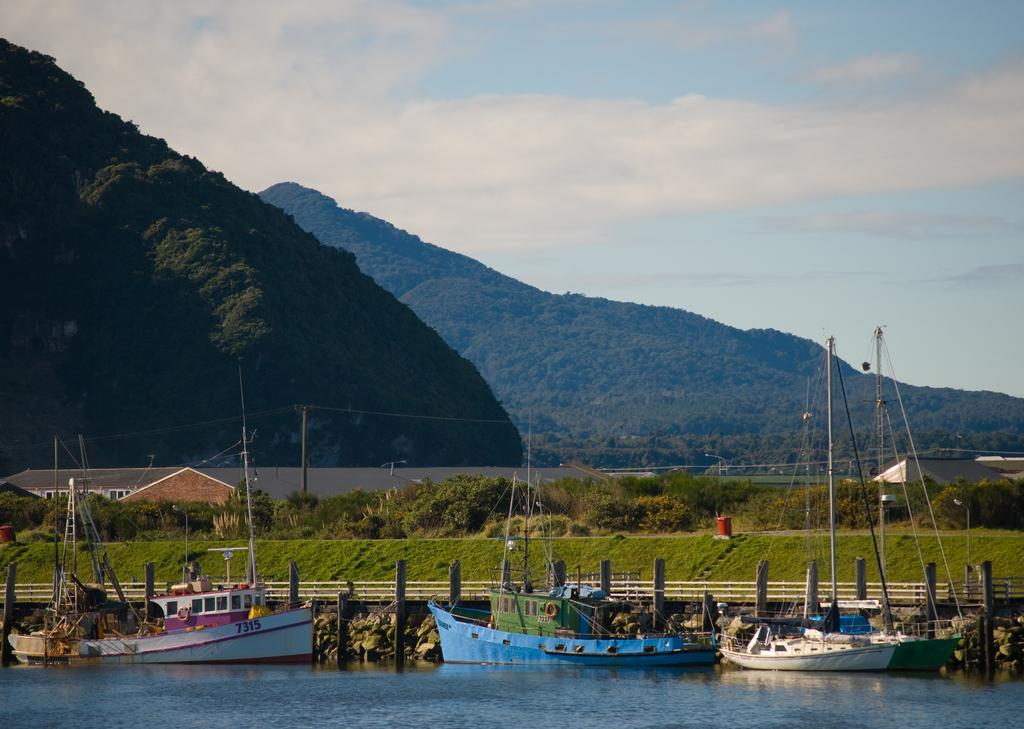What type of landscape is depicted in the image? The image features hills, trees, and buildings. Are there any water features in the image? Yes, there are boats in the water in the image. What is the condition of the sky in the image? The sky is blue and cloudy. How many oranges are being used to make the bread in the image? There are no oranges or bread present in the image. 